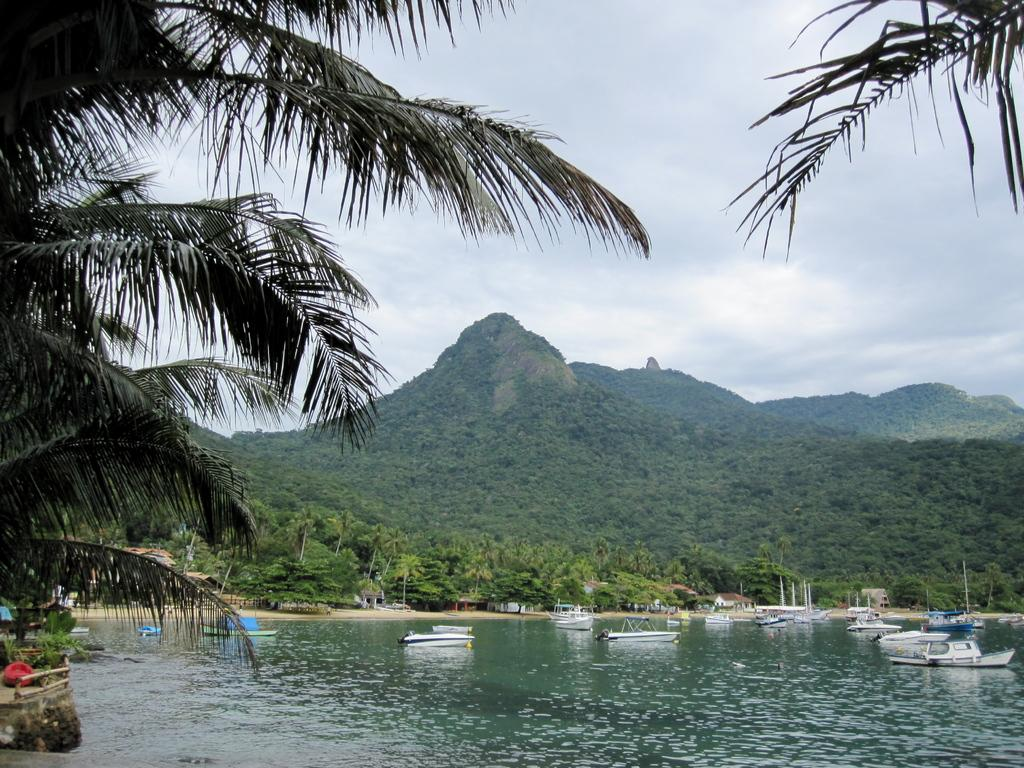What can be seen in the water body in the image? There are boats in a water body in the image. What structures are present in the image? There are poles in the image. What type of vegetation is visible in the image? There is a group of trees in the image. What geographical features can be seen in the image? There are hills visible in the image. What is the condition of the sky in the image? The sky is cloudy in the image. What type of bomb can be seen in the image? There is no bomb present in the image. How does the acoustics of the image affect the sound quality? The image is a visual representation and does not have acoustics, so it cannot affect sound quality. 